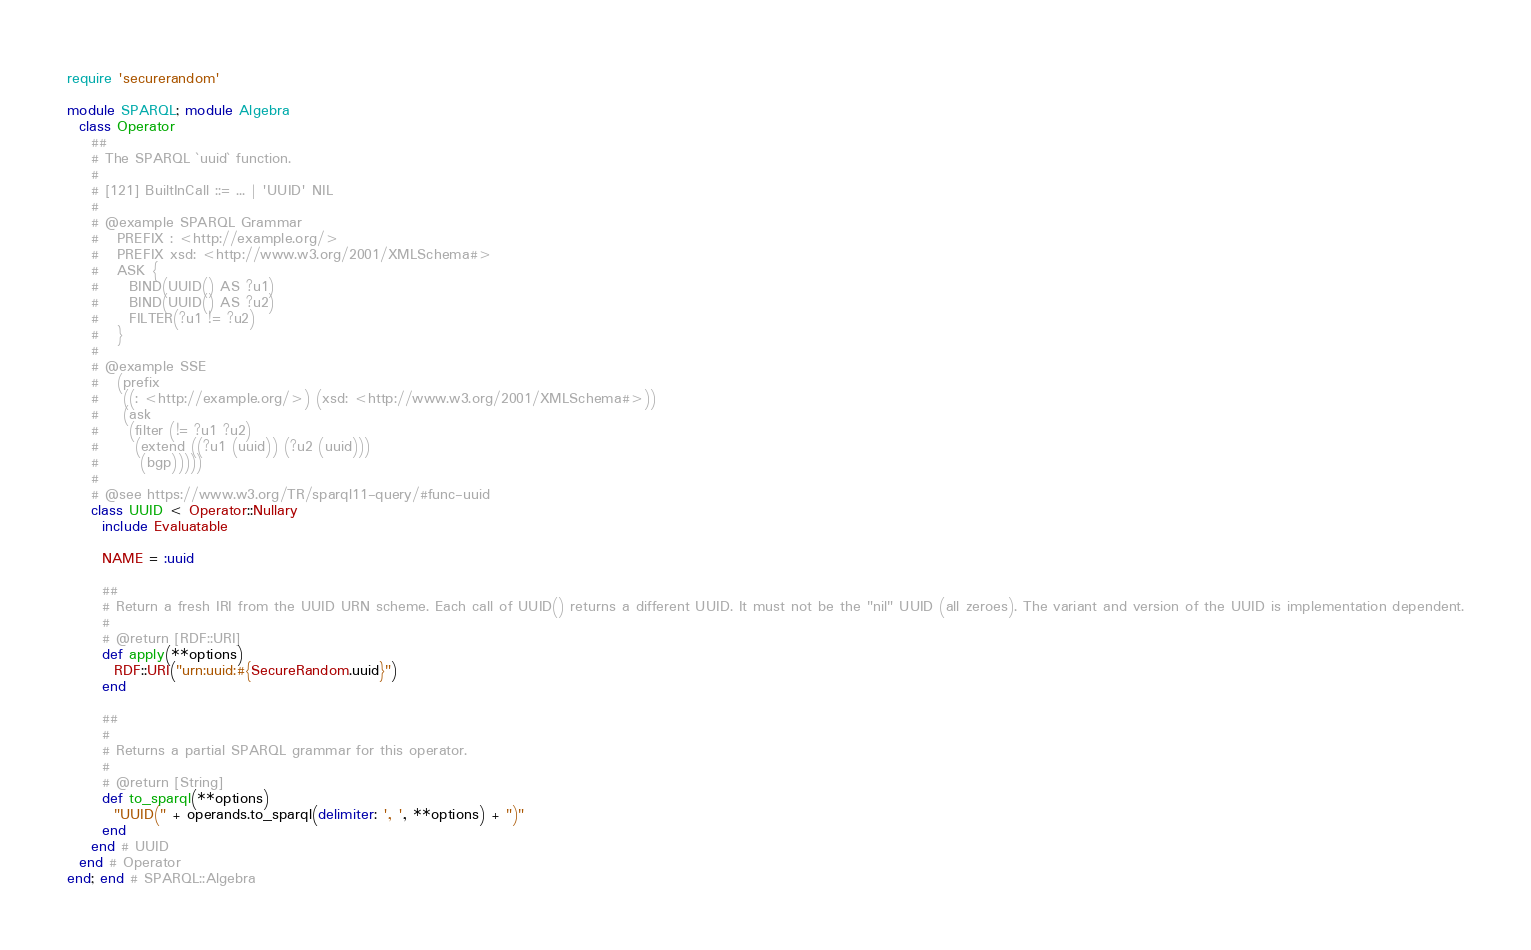<code> <loc_0><loc_0><loc_500><loc_500><_Ruby_>require 'securerandom'

module SPARQL; module Algebra
  class Operator
    ##
    # The SPARQL `uuid` function.
    #
    # [121] BuiltInCall ::= ... | 'UUID' NIL 
    #
    # @example SPARQL Grammar
    #   PREFIX : <http://example.org/>
    #   PREFIX xsd: <http://www.w3.org/2001/XMLSchema#>
    #   ASK {
    #     BIND(UUID() AS ?u1)
    #     BIND(UUID() AS ?u2)
    #     FILTER(?u1 != ?u2)
    #   }
    #
    # @example SSE
    #   (prefix
    #    ((: <http://example.org/>) (xsd: <http://www.w3.org/2001/XMLSchema#>))
    #    (ask
    #     (filter (!= ?u1 ?u2)
    #      (extend ((?u1 (uuid)) (?u2 (uuid)))
    #       (bgp)))))
    #
    # @see https://www.w3.org/TR/sparql11-query/#func-uuid
    class UUID < Operator::Nullary
      include Evaluatable

      NAME = :uuid

      ##
      # Return a fresh IRI from the UUID URN scheme. Each call of UUID() returns a different UUID. It must not be the "nil" UUID (all zeroes). The variant and version of the UUID is implementation dependent.
      #
      # @return [RDF::URI]
      def apply(**options)
        RDF::URI("urn:uuid:#{SecureRandom.uuid}")
      end

      ##
      #
      # Returns a partial SPARQL grammar for this operator.
      #
      # @return [String]
      def to_sparql(**options)
        "UUID(" + operands.to_sparql(delimiter: ', ', **options) + ")"
      end
    end # UUID
  end # Operator
end; end # SPARQL::Algebra
</code> 